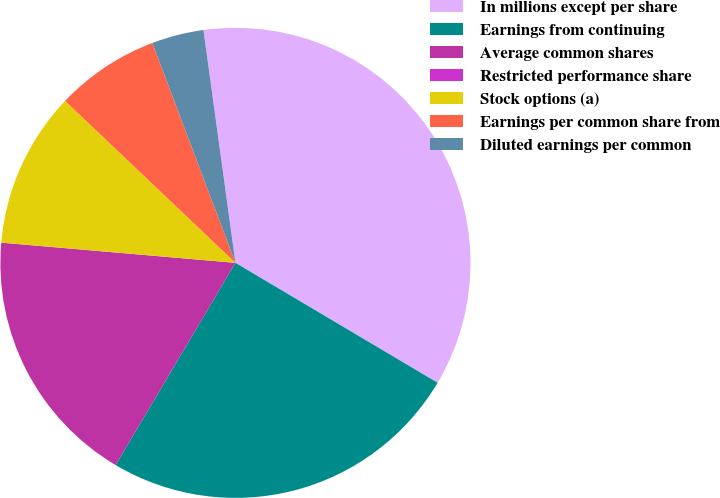<chart> <loc_0><loc_0><loc_500><loc_500><pie_chart><fcel>In millions except per share<fcel>Earnings from continuing<fcel>Average common shares<fcel>Restricted performance share<fcel>Stock options (a)<fcel>Earnings per common share from<fcel>Diluted earnings per common<nl><fcel>35.69%<fcel>24.99%<fcel>17.85%<fcel>0.01%<fcel>10.72%<fcel>7.15%<fcel>3.58%<nl></chart> 